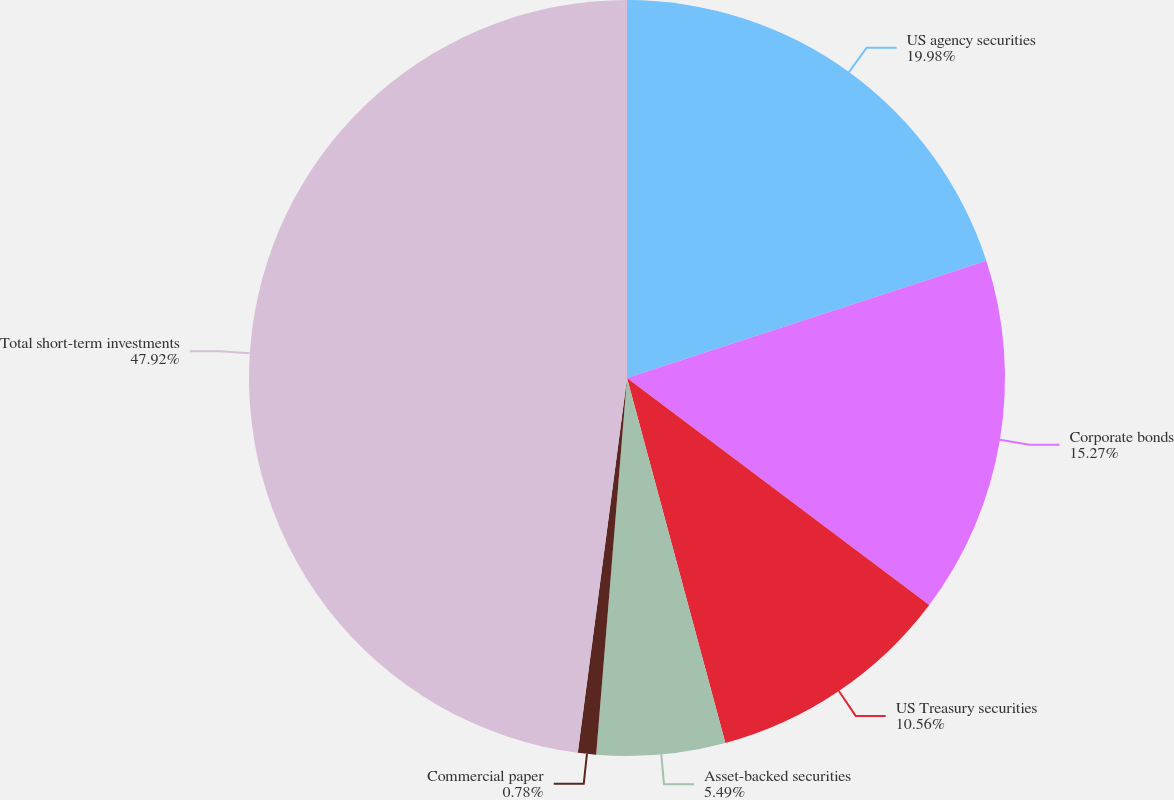Convert chart to OTSL. <chart><loc_0><loc_0><loc_500><loc_500><pie_chart><fcel>US agency securities<fcel>Corporate bonds<fcel>US Treasury securities<fcel>Asset-backed securities<fcel>Commercial paper<fcel>Total short-term investments<nl><fcel>19.98%<fcel>15.27%<fcel>10.56%<fcel>5.49%<fcel>0.78%<fcel>47.92%<nl></chart> 